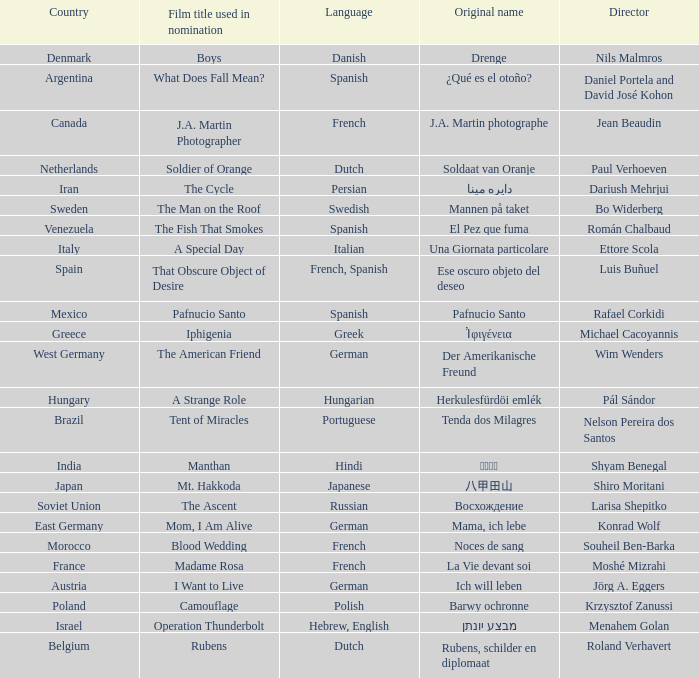Which director is from Italy? Ettore Scola. 